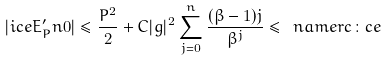<formula> <loc_0><loc_0><loc_500><loc_500>| \sl i c e { E ^ { \prime } _ { P } } { n } { 0 } | \leq \frac { P ^ { 2 } } { 2 } + C | g | ^ { 2 } \sum _ { j = 0 } ^ { n } \frac { ( \beta - 1 ) j } { \beta ^ { j } } \leq \ n a m e r { c \colon c e }</formula> 